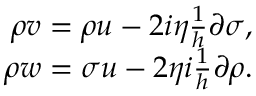<formula> <loc_0><loc_0><loc_500><loc_500>\begin{array} { r } { \rho v = \rho u - 2 i \eta \frac { 1 } { h } \partial \sigma , } \\ { \rho w = \sigma u - 2 \eta i \frac { 1 } { h } \partial \rho . } \end{array}</formula> 